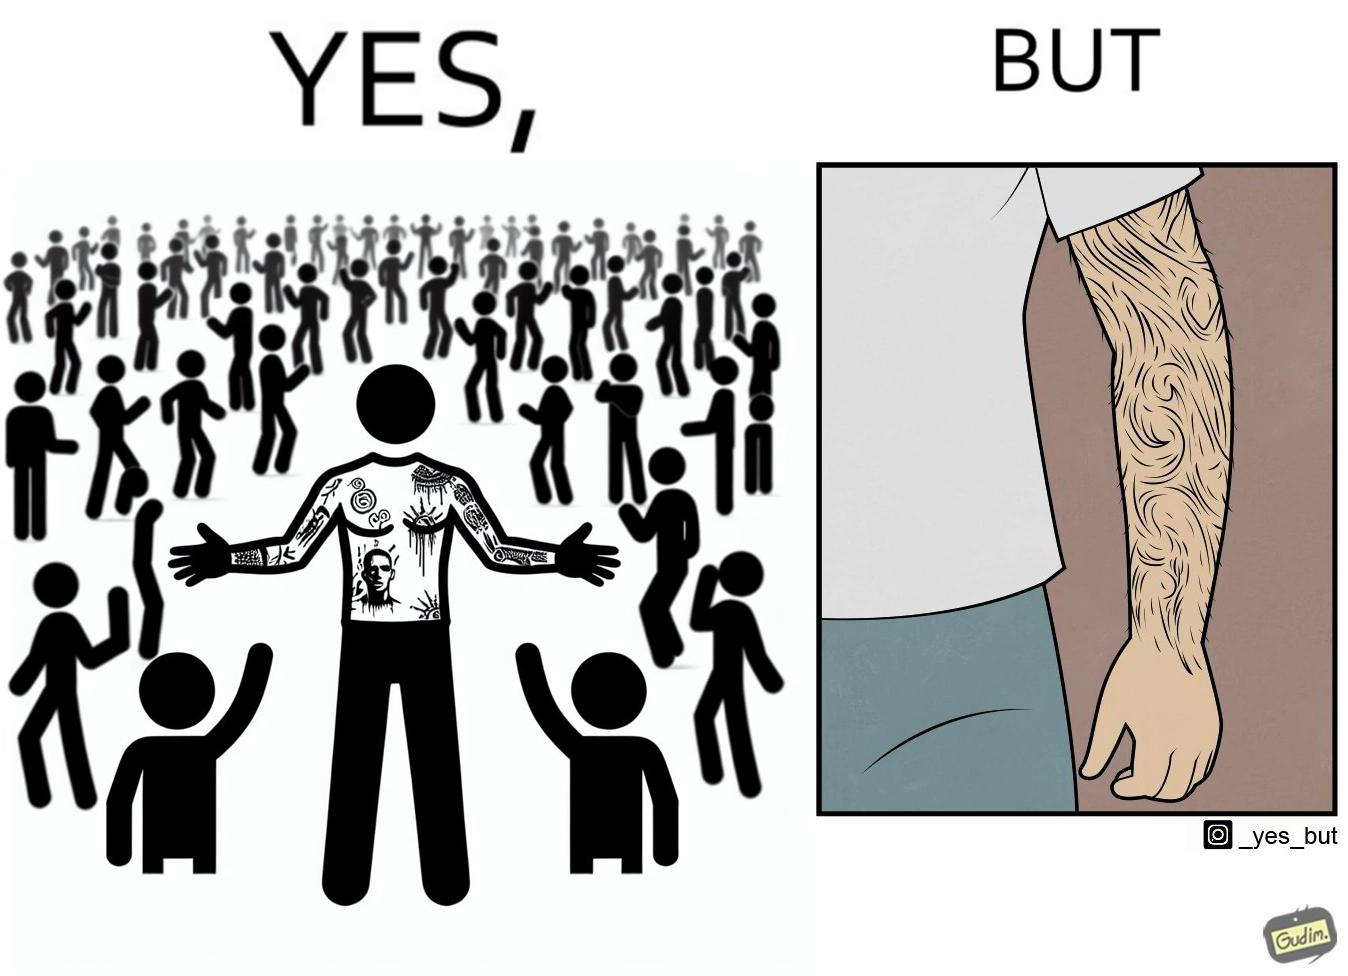Describe the content of this image. The image is funny because while from the distance it seems that the man has big tattoos on both of his arms upon a closer look at the arms it turns out there is no tattoo and what seemed to be tattoos are just hairs on his arm. 